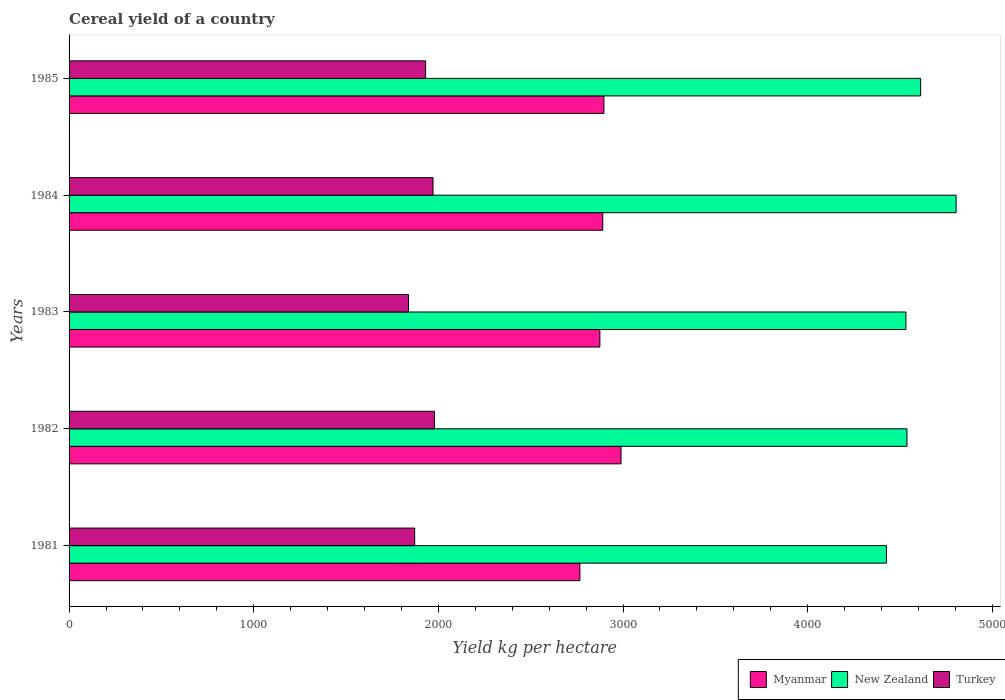How many different coloured bars are there?
Your response must be concise. 3. How many groups of bars are there?
Provide a short and direct response. 5. Are the number of bars per tick equal to the number of legend labels?
Your response must be concise. Yes. How many bars are there on the 2nd tick from the bottom?
Ensure brevity in your answer.  3. In how many cases, is the number of bars for a given year not equal to the number of legend labels?
Keep it short and to the point. 0. What is the total cereal yield in Turkey in 1981?
Make the answer very short. 1871.71. Across all years, what is the maximum total cereal yield in New Zealand?
Offer a terse response. 4804.07. Across all years, what is the minimum total cereal yield in Myanmar?
Give a very brief answer. 2766.45. In which year was the total cereal yield in Turkey maximum?
Make the answer very short. 1982. In which year was the total cereal yield in Myanmar minimum?
Provide a short and direct response. 1981. What is the total total cereal yield in Myanmar in the graph?
Give a very brief answer. 1.44e+04. What is the difference between the total cereal yield in Turkey in 1981 and that in 1982?
Ensure brevity in your answer.  -107.03. What is the difference between the total cereal yield in Turkey in 1984 and the total cereal yield in Myanmar in 1982?
Keep it short and to the point. -1018.03. What is the average total cereal yield in New Zealand per year?
Provide a succinct answer. 4582.46. In the year 1985, what is the difference between the total cereal yield in New Zealand and total cereal yield in Turkey?
Keep it short and to the point. 2680.77. In how many years, is the total cereal yield in Turkey greater than 600 kg per hectare?
Provide a succinct answer. 5. What is the ratio of the total cereal yield in New Zealand in 1982 to that in 1983?
Offer a very short reply. 1. What is the difference between the highest and the second highest total cereal yield in Turkey?
Provide a short and direct response. 7.63. What is the difference between the highest and the lowest total cereal yield in Turkey?
Offer a terse response. 140.34. What does the 3rd bar from the top in 1985 represents?
Offer a terse response. Myanmar. What does the 1st bar from the bottom in 1983 represents?
Keep it short and to the point. Myanmar. How many bars are there?
Your response must be concise. 15. How many years are there in the graph?
Keep it short and to the point. 5. Are the values on the major ticks of X-axis written in scientific E-notation?
Offer a terse response. No. Does the graph contain any zero values?
Your response must be concise. No. Where does the legend appear in the graph?
Ensure brevity in your answer.  Bottom right. How many legend labels are there?
Make the answer very short. 3. How are the legend labels stacked?
Ensure brevity in your answer.  Horizontal. What is the title of the graph?
Make the answer very short. Cereal yield of a country. What is the label or title of the X-axis?
Your answer should be very brief. Yield kg per hectare. What is the label or title of the Y-axis?
Your response must be concise. Years. What is the Yield kg per hectare of Myanmar in 1981?
Provide a short and direct response. 2766.45. What is the Yield kg per hectare in New Zealand in 1981?
Provide a succinct answer. 4426.62. What is the Yield kg per hectare in Turkey in 1981?
Make the answer very short. 1871.71. What is the Yield kg per hectare of Myanmar in 1982?
Offer a terse response. 2989.14. What is the Yield kg per hectare of New Zealand in 1982?
Your response must be concise. 4537.68. What is the Yield kg per hectare in Turkey in 1982?
Provide a succinct answer. 1978.74. What is the Yield kg per hectare of Myanmar in 1983?
Keep it short and to the point. 2874.68. What is the Yield kg per hectare in New Zealand in 1983?
Offer a very short reply. 4532.1. What is the Yield kg per hectare in Turkey in 1983?
Give a very brief answer. 1838.4. What is the Yield kg per hectare in Myanmar in 1984?
Offer a terse response. 2890.35. What is the Yield kg per hectare of New Zealand in 1984?
Make the answer very short. 4804.07. What is the Yield kg per hectare in Turkey in 1984?
Your response must be concise. 1971.1. What is the Yield kg per hectare in Myanmar in 1985?
Offer a terse response. 2896.66. What is the Yield kg per hectare in New Zealand in 1985?
Provide a short and direct response. 4611.81. What is the Yield kg per hectare in Turkey in 1985?
Your response must be concise. 1931.04. Across all years, what is the maximum Yield kg per hectare in Myanmar?
Your response must be concise. 2989.14. Across all years, what is the maximum Yield kg per hectare of New Zealand?
Your response must be concise. 4804.07. Across all years, what is the maximum Yield kg per hectare in Turkey?
Give a very brief answer. 1978.74. Across all years, what is the minimum Yield kg per hectare of Myanmar?
Provide a short and direct response. 2766.45. Across all years, what is the minimum Yield kg per hectare of New Zealand?
Ensure brevity in your answer.  4426.62. Across all years, what is the minimum Yield kg per hectare in Turkey?
Your response must be concise. 1838.4. What is the total Yield kg per hectare of Myanmar in the graph?
Ensure brevity in your answer.  1.44e+04. What is the total Yield kg per hectare of New Zealand in the graph?
Your answer should be very brief. 2.29e+04. What is the total Yield kg per hectare of Turkey in the graph?
Offer a terse response. 9590.99. What is the difference between the Yield kg per hectare of Myanmar in 1981 and that in 1982?
Give a very brief answer. -222.69. What is the difference between the Yield kg per hectare in New Zealand in 1981 and that in 1982?
Offer a very short reply. -111.06. What is the difference between the Yield kg per hectare in Turkey in 1981 and that in 1982?
Provide a short and direct response. -107.03. What is the difference between the Yield kg per hectare in Myanmar in 1981 and that in 1983?
Offer a terse response. -108.23. What is the difference between the Yield kg per hectare in New Zealand in 1981 and that in 1983?
Keep it short and to the point. -105.49. What is the difference between the Yield kg per hectare in Turkey in 1981 and that in 1983?
Keep it short and to the point. 33.31. What is the difference between the Yield kg per hectare of Myanmar in 1981 and that in 1984?
Provide a short and direct response. -123.9. What is the difference between the Yield kg per hectare in New Zealand in 1981 and that in 1984?
Give a very brief answer. -377.45. What is the difference between the Yield kg per hectare in Turkey in 1981 and that in 1984?
Provide a succinct answer. -99.39. What is the difference between the Yield kg per hectare in Myanmar in 1981 and that in 1985?
Offer a very short reply. -130.21. What is the difference between the Yield kg per hectare of New Zealand in 1981 and that in 1985?
Your response must be concise. -185.19. What is the difference between the Yield kg per hectare of Turkey in 1981 and that in 1985?
Make the answer very short. -59.33. What is the difference between the Yield kg per hectare in Myanmar in 1982 and that in 1983?
Ensure brevity in your answer.  114.45. What is the difference between the Yield kg per hectare in New Zealand in 1982 and that in 1983?
Offer a very short reply. 5.57. What is the difference between the Yield kg per hectare in Turkey in 1982 and that in 1983?
Your response must be concise. 140.34. What is the difference between the Yield kg per hectare of Myanmar in 1982 and that in 1984?
Provide a succinct answer. 98.79. What is the difference between the Yield kg per hectare in New Zealand in 1982 and that in 1984?
Provide a short and direct response. -266.4. What is the difference between the Yield kg per hectare in Turkey in 1982 and that in 1984?
Give a very brief answer. 7.63. What is the difference between the Yield kg per hectare of Myanmar in 1982 and that in 1985?
Ensure brevity in your answer.  92.48. What is the difference between the Yield kg per hectare of New Zealand in 1982 and that in 1985?
Offer a very short reply. -74.14. What is the difference between the Yield kg per hectare of Turkey in 1982 and that in 1985?
Your response must be concise. 47.7. What is the difference between the Yield kg per hectare in Myanmar in 1983 and that in 1984?
Offer a very short reply. -15.66. What is the difference between the Yield kg per hectare in New Zealand in 1983 and that in 1984?
Give a very brief answer. -271.97. What is the difference between the Yield kg per hectare in Turkey in 1983 and that in 1984?
Your response must be concise. -132.7. What is the difference between the Yield kg per hectare of Myanmar in 1983 and that in 1985?
Ensure brevity in your answer.  -21.98. What is the difference between the Yield kg per hectare in New Zealand in 1983 and that in 1985?
Make the answer very short. -79.71. What is the difference between the Yield kg per hectare in Turkey in 1983 and that in 1985?
Offer a very short reply. -92.63. What is the difference between the Yield kg per hectare in Myanmar in 1984 and that in 1985?
Provide a succinct answer. -6.31. What is the difference between the Yield kg per hectare of New Zealand in 1984 and that in 1985?
Keep it short and to the point. 192.26. What is the difference between the Yield kg per hectare of Turkey in 1984 and that in 1985?
Your answer should be compact. 40.07. What is the difference between the Yield kg per hectare in Myanmar in 1981 and the Yield kg per hectare in New Zealand in 1982?
Your response must be concise. -1771.22. What is the difference between the Yield kg per hectare in Myanmar in 1981 and the Yield kg per hectare in Turkey in 1982?
Your answer should be compact. 787.71. What is the difference between the Yield kg per hectare in New Zealand in 1981 and the Yield kg per hectare in Turkey in 1982?
Keep it short and to the point. 2447.88. What is the difference between the Yield kg per hectare of Myanmar in 1981 and the Yield kg per hectare of New Zealand in 1983?
Provide a short and direct response. -1765.65. What is the difference between the Yield kg per hectare in Myanmar in 1981 and the Yield kg per hectare in Turkey in 1983?
Give a very brief answer. 928.05. What is the difference between the Yield kg per hectare of New Zealand in 1981 and the Yield kg per hectare of Turkey in 1983?
Ensure brevity in your answer.  2588.22. What is the difference between the Yield kg per hectare of Myanmar in 1981 and the Yield kg per hectare of New Zealand in 1984?
Ensure brevity in your answer.  -2037.62. What is the difference between the Yield kg per hectare in Myanmar in 1981 and the Yield kg per hectare in Turkey in 1984?
Provide a short and direct response. 795.35. What is the difference between the Yield kg per hectare in New Zealand in 1981 and the Yield kg per hectare in Turkey in 1984?
Offer a very short reply. 2455.51. What is the difference between the Yield kg per hectare of Myanmar in 1981 and the Yield kg per hectare of New Zealand in 1985?
Provide a succinct answer. -1845.36. What is the difference between the Yield kg per hectare of Myanmar in 1981 and the Yield kg per hectare of Turkey in 1985?
Offer a very short reply. 835.41. What is the difference between the Yield kg per hectare of New Zealand in 1981 and the Yield kg per hectare of Turkey in 1985?
Ensure brevity in your answer.  2495.58. What is the difference between the Yield kg per hectare in Myanmar in 1982 and the Yield kg per hectare in New Zealand in 1983?
Ensure brevity in your answer.  -1542.97. What is the difference between the Yield kg per hectare of Myanmar in 1982 and the Yield kg per hectare of Turkey in 1983?
Your answer should be very brief. 1150.73. What is the difference between the Yield kg per hectare of New Zealand in 1982 and the Yield kg per hectare of Turkey in 1983?
Provide a succinct answer. 2699.27. What is the difference between the Yield kg per hectare in Myanmar in 1982 and the Yield kg per hectare in New Zealand in 1984?
Your response must be concise. -1814.93. What is the difference between the Yield kg per hectare in Myanmar in 1982 and the Yield kg per hectare in Turkey in 1984?
Make the answer very short. 1018.03. What is the difference between the Yield kg per hectare in New Zealand in 1982 and the Yield kg per hectare in Turkey in 1984?
Your answer should be very brief. 2566.57. What is the difference between the Yield kg per hectare of Myanmar in 1982 and the Yield kg per hectare of New Zealand in 1985?
Ensure brevity in your answer.  -1622.67. What is the difference between the Yield kg per hectare of Myanmar in 1982 and the Yield kg per hectare of Turkey in 1985?
Your response must be concise. 1058.1. What is the difference between the Yield kg per hectare of New Zealand in 1982 and the Yield kg per hectare of Turkey in 1985?
Provide a short and direct response. 2606.64. What is the difference between the Yield kg per hectare of Myanmar in 1983 and the Yield kg per hectare of New Zealand in 1984?
Give a very brief answer. -1929.39. What is the difference between the Yield kg per hectare in Myanmar in 1983 and the Yield kg per hectare in Turkey in 1984?
Provide a succinct answer. 903.58. What is the difference between the Yield kg per hectare in New Zealand in 1983 and the Yield kg per hectare in Turkey in 1984?
Provide a succinct answer. 2561. What is the difference between the Yield kg per hectare of Myanmar in 1983 and the Yield kg per hectare of New Zealand in 1985?
Make the answer very short. -1737.13. What is the difference between the Yield kg per hectare of Myanmar in 1983 and the Yield kg per hectare of Turkey in 1985?
Give a very brief answer. 943.65. What is the difference between the Yield kg per hectare in New Zealand in 1983 and the Yield kg per hectare in Turkey in 1985?
Offer a terse response. 2601.07. What is the difference between the Yield kg per hectare in Myanmar in 1984 and the Yield kg per hectare in New Zealand in 1985?
Your response must be concise. -1721.46. What is the difference between the Yield kg per hectare of Myanmar in 1984 and the Yield kg per hectare of Turkey in 1985?
Keep it short and to the point. 959.31. What is the difference between the Yield kg per hectare of New Zealand in 1984 and the Yield kg per hectare of Turkey in 1985?
Your answer should be compact. 2873.03. What is the average Yield kg per hectare in Myanmar per year?
Your response must be concise. 2883.46. What is the average Yield kg per hectare in New Zealand per year?
Provide a short and direct response. 4582.46. What is the average Yield kg per hectare in Turkey per year?
Ensure brevity in your answer.  1918.2. In the year 1981, what is the difference between the Yield kg per hectare of Myanmar and Yield kg per hectare of New Zealand?
Offer a very short reply. -1660.17. In the year 1981, what is the difference between the Yield kg per hectare in Myanmar and Yield kg per hectare in Turkey?
Keep it short and to the point. 894.74. In the year 1981, what is the difference between the Yield kg per hectare in New Zealand and Yield kg per hectare in Turkey?
Keep it short and to the point. 2554.91. In the year 1982, what is the difference between the Yield kg per hectare in Myanmar and Yield kg per hectare in New Zealand?
Give a very brief answer. -1548.54. In the year 1982, what is the difference between the Yield kg per hectare of Myanmar and Yield kg per hectare of Turkey?
Give a very brief answer. 1010.4. In the year 1982, what is the difference between the Yield kg per hectare in New Zealand and Yield kg per hectare in Turkey?
Make the answer very short. 2558.94. In the year 1983, what is the difference between the Yield kg per hectare in Myanmar and Yield kg per hectare in New Zealand?
Keep it short and to the point. -1657.42. In the year 1983, what is the difference between the Yield kg per hectare of Myanmar and Yield kg per hectare of Turkey?
Offer a very short reply. 1036.28. In the year 1983, what is the difference between the Yield kg per hectare in New Zealand and Yield kg per hectare in Turkey?
Keep it short and to the point. 2693.7. In the year 1984, what is the difference between the Yield kg per hectare of Myanmar and Yield kg per hectare of New Zealand?
Give a very brief answer. -1913.72. In the year 1984, what is the difference between the Yield kg per hectare in Myanmar and Yield kg per hectare in Turkey?
Make the answer very short. 919.24. In the year 1984, what is the difference between the Yield kg per hectare of New Zealand and Yield kg per hectare of Turkey?
Offer a terse response. 2832.97. In the year 1985, what is the difference between the Yield kg per hectare in Myanmar and Yield kg per hectare in New Zealand?
Offer a terse response. -1715.15. In the year 1985, what is the difference between the Yield kg per hectare in Myanmar and Yield kg per hectare in Turkey?
Provide a succinct answer. 965.62. In the year 1985, what is the difference between the Yield kg per hectare of New Zealand and Yield kg per hectare of Turkey?
Give a very brief answer. 2680.77. What is the ratio of the Yield kg per hectare of Myanmar in 1981 to that in 1982?
Keep it short and to the point. 0.93. What is the ratio of the Yield kg per hectare in New Zealand in 1981 to that in 1982?
Ensure brevity in your answer.  0.98. What is the ratio of the Yield kg per hectare of Turkey in 1981 to that in 1982?
Your response must be concise. 0.95. What is the ratio of the Yield kg per hectare of Myanmar in 1981 to that in 1983?
Give a very brief answer. 0.96. What is the ratio of the Yield kg per hectare of New Zealand in 1981 to that in 1983?
Keep it short and to the point. 0.98. What is the ratio of the Yield kg per hectare in Turkey in 1981 to that in 1983?
Ensure brevity in your answer.  1.02. What is the ratio of the Yield kg per hectare in Myanmar in 1981 to that in 1984?
Give a very brief answer. 0.96. What is the ratio of the Yield kg per hectare in New Zealand in 1981 to that in 1984?
Your answer should be compact. 0.92. What is the ratio of the Yield kg per hectare of Turkey in 1981 to that in 1984?
Your answer should be compact. 0.95. What is the ratio of the Yield kg per hectare in Myanmar in 1981 to that in 1985?
Your answer should be compact. 0.95. What is the ratio of the Yield kg per hectare in New Zealand in 1981 to that in 1985?
Keep it short and to the point. 0.96. What is the ratio of the Yield kg per hectare of Turkey in 1981 to that in 1985?
Provide a succinct answer. 0.97. What is the ratio of the Yield kg per hectare in Myanmar in 1982 to that in 1983?
Your answer should be very brief. 1.04. What is the ratio of the Yield kg per hectare in New Zealand in 1982 to that in 1983?
Ensure brevity in your answer.  1. What is the ratio of the Yield kg per hectare in Turkey in 1982 to that in 1983?
Your response must be concise. 1.08. What is the ratio of the Yield kg per hectare of Myanmar in 1982 to that in 1984?
Ensure brevity in your answer.  1.03. What is the ratio of the Yield kg per hectare in New Zealand in 1982 to that in 1984?
Your answer should be compact. 0.94. What is the ratio of the Yield kg per hectare of Myanmar in 1982 to that in 1985?
Provide a short and direct response. 1.03. What is the ratio of the Yield kg per hectare of New Zealand in 1982 to that in 1985?
Offer a very short reply. 0.98. What is the ratio of the Yield kg per hectare in Turkey in 1982 to that in 1985?
Offer a very short reply. 1.02. What is the ratio of the Yield kg per hectare in New Zealand in 1983 to that in 1984?
Provide a succinct answer. 0.94. What is the ratio of the Yield kg per hectare in Turkey in 1983 to that in 1984?
Keep it short and to the point. 0.93. What is the ratio of the Yield kg per hectare in New Zealand in 1983 to that in 1985?
Your response must be concise. 0.98. What is the ratio of the Yield kg per hectare of Myanmar in 1984 to that in 1985?
Ensure brevity in your answer.  1. What is the ratio of the Yield kg per hectare of New Zealand in 1984 to that in 1985?
Keep it short and to the point. 1.04. What is the ratio of the Yield kg per hectare in Turkey in 1984 to that in 1985?
Offer a very short reply. 1.02. What is the difference between the highest and the second highest Yield kg per hectare of Myanmar?
Keep it short and to the point. 92.48. What is the difference between the highest and the second highest Yield kg per hectare in New Zealand?
Ensure brevity in your answer.  192.26. What is the difference between the highest and the second highest Yield kg per hectare in Turkey?
Ensure brevity in your answer.  7.63. What is the difference between the highest and the lowest Yield kg per hectare of Myanmar?
Your answer should be compact. 222.69. What is the difference between the highest and the lowest Yield kg per hectare in New Zealand?
Your answer should be compact. 377.45. What is the difference between the highest and the lowest Yield kg per hectare in Turkey?
Your response must be concise. 140.34. 